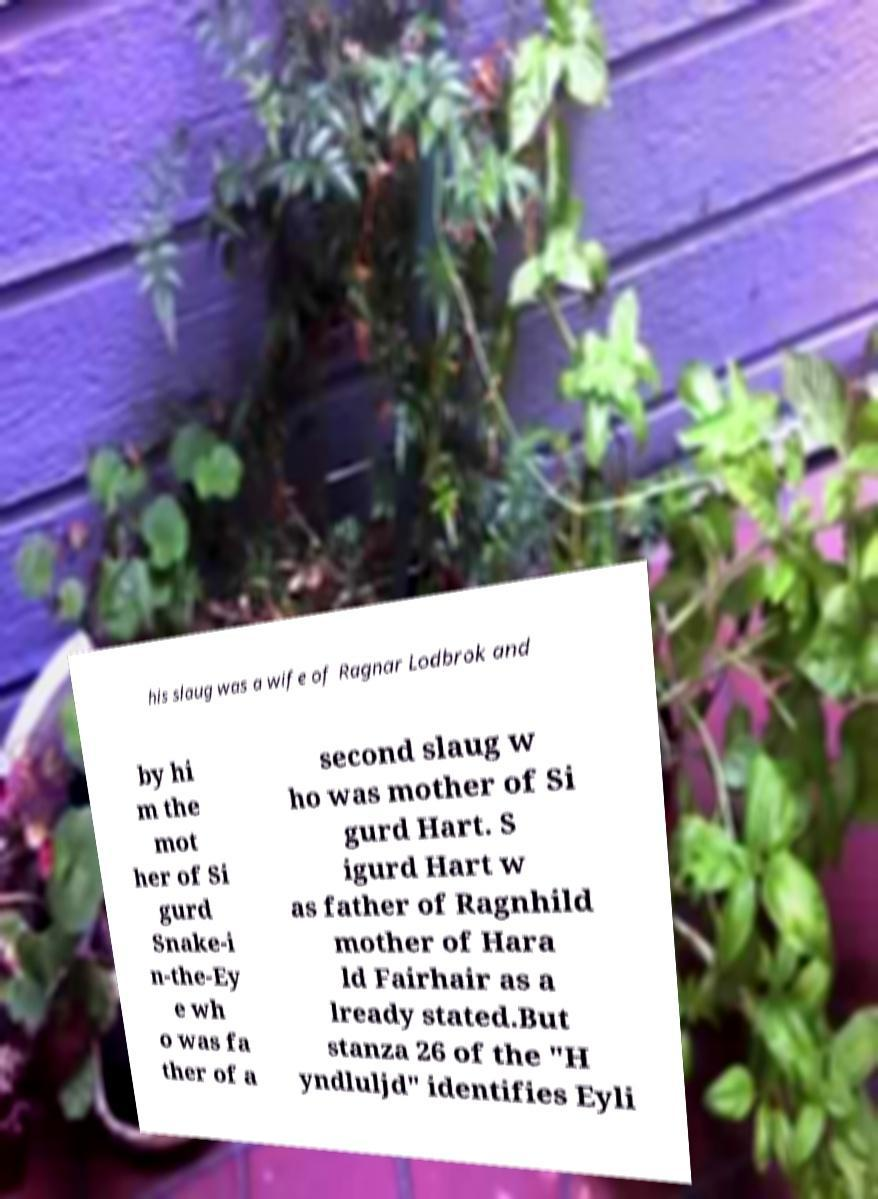Please identify and transcribe the text found in this image. his slaug was a wife of Ragnar Lodbrok and by hi m the mot her of Si gurd Snake-i n-the-Ey e wh o was fa ther of a second slaug w ho was mother of Si gurd Hart. S igurd Hart w as father of Ragnhild mother of Hara ld Fairhair as a lready stated.But stanza 26 of the "H yndluljd" identifies Eyli 